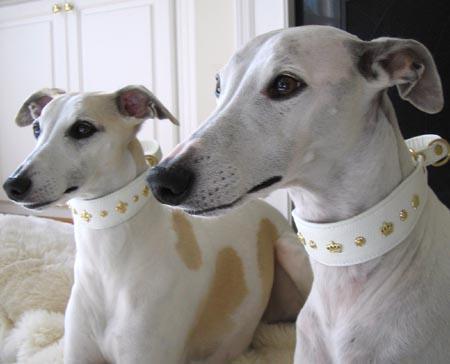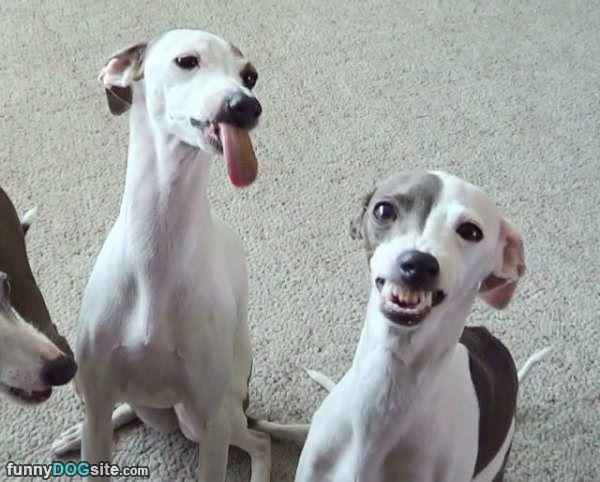The first image is the image on the left, the second image is the image on the right. Evaluate the accuracy of this statement regarding the images: "There are no more than two Italian greyhounds, all wearing collars.". Is it true? Answer yes or no. No. The first image is the image on the left, the second image is the image on the right. For the images shown, is this caption "There are four dogs." true? Answer yes or no. Yes. 